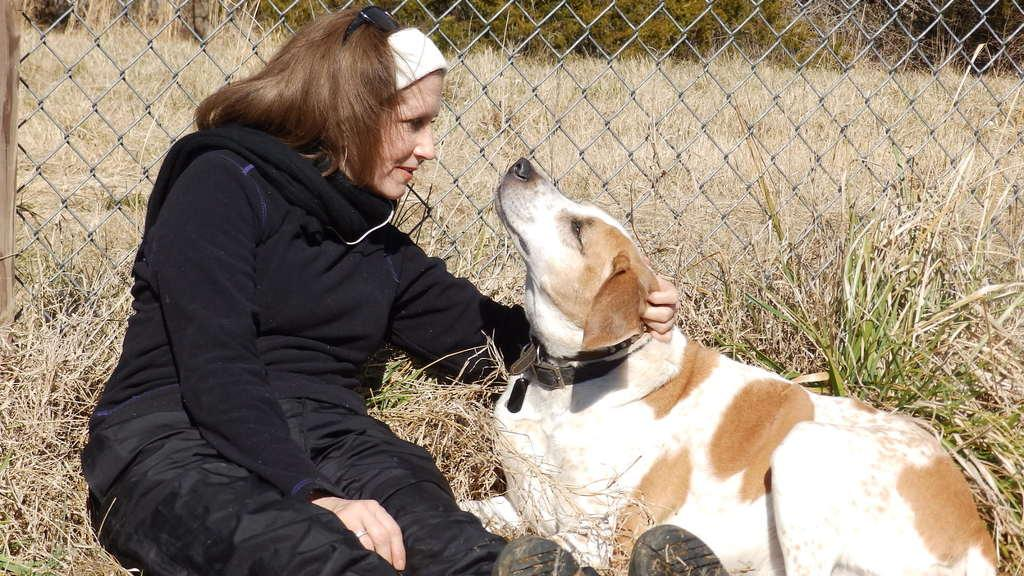Who is present in the image? There is a woman in the image. What is the woman sitting on? The woman is sitting on dried grass. What is the woman holding in the image? The woman is holding a dog. What can be seen in the background of the image? There are plants and a wire fence in the background of the image. What type of brush is the woman using to paint the stage in the image? There is no stage, brush, or painting activity present in the image. 